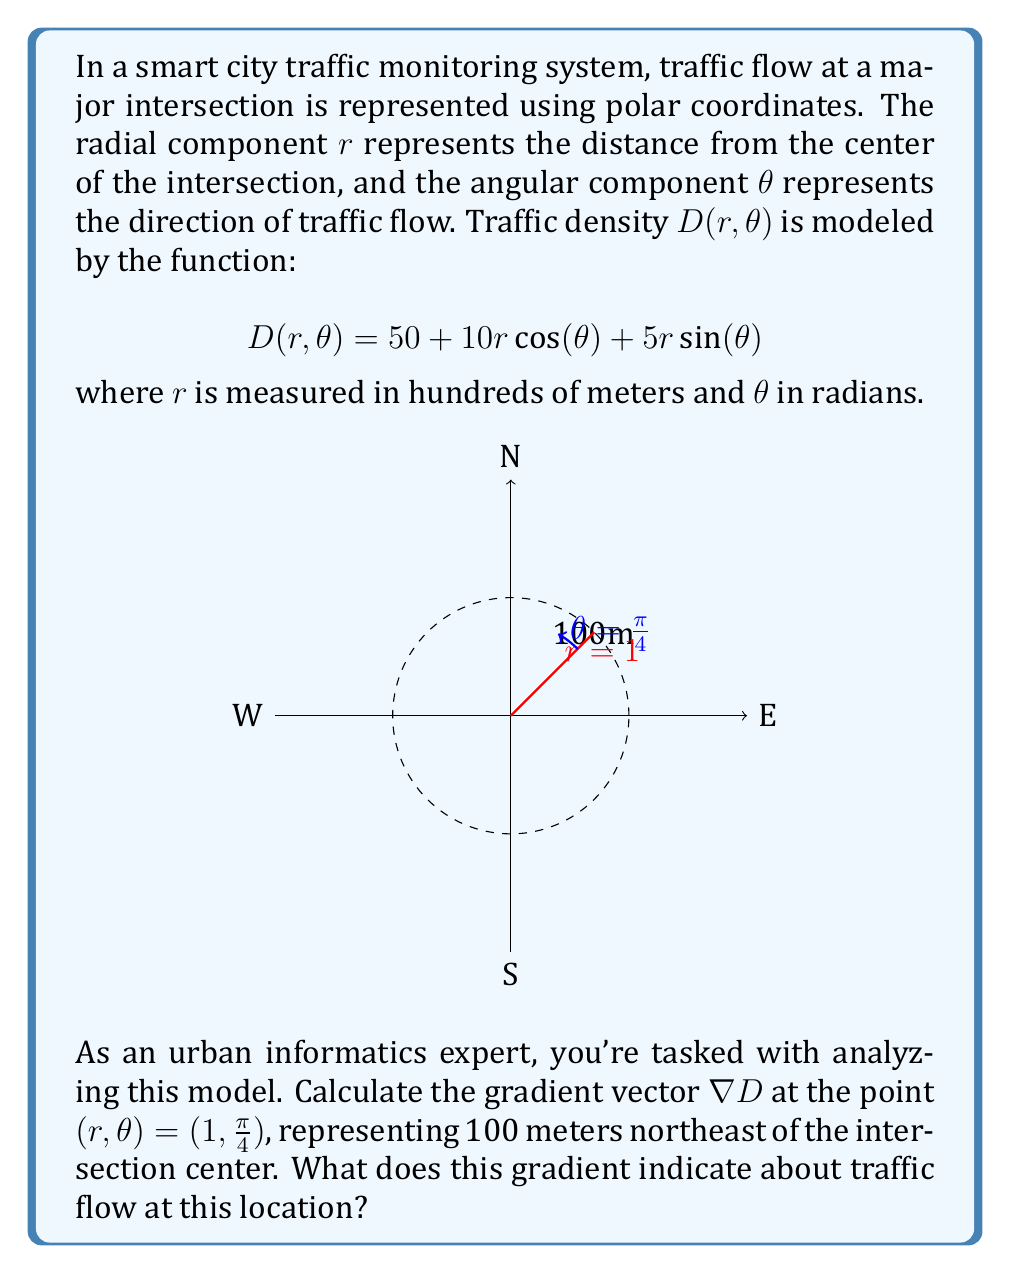Solve this math problem. To solve this problem, we need to follow these steps:

1) First, we need to calculate the partial derivatives of $D$ with respect to $r$ and $\theta$:

   $$\frac{\partial D}{\partial r} = 10\cos(\theta) + 5\sin(\theta)$$
   $$\frac{\partial D}{\partial \theta} = -10r\sin(\theta) + 5r\cos(\theta)$$

2) The gradient in polar coordinates is given by:

   $$\nabla D = \frac{\partial D}{\partial r}\hat{r} + \frac{1}{r}\frac{\partial D}{\partial \theta}\hat{\theta}$$

3) Now, we evaluate these at the point $(r,\theta) = (1, \frac{\pi}{4})$:

   $$\frac{\partial D}{\partial r}\bigg|_{(1,\frac{\pi}{4})} = 10\cos(\frac{\pi}{4}) + 5\sin(\frac{\pi}{4}) = 10\cdot\frac{\sqrt{2}}{2} + 5\cdot\frac{\sqrt{2}}{2} = \frac{15\sqrt{2}}{2}$$

   $$\frac{\partial D}{\partial \theta}\bigg|_{(1,\frac{\pi}{4})} = -10\sin(\frac{\pi}{4}) + 5\cos(\frac{\pi}{4}) = -10\cdot\frac{\sqrt{2}}{2} + 5\cdot\frac{\sqrt{2}}{2} = -\frac{5\sqrt{2}}{2}$$

4) Substituting these values into the gradient formula:

   $$\nabla D = \frac{15\sqrt{2}}{2}\hat{r} + \frac{1}{1}\cdot(-\frac{5\sqrt{2}}{2})\hat{\theta} = \frac{15\sqrt{2}}{2}\hat{r} - \frac{5\sqrt{2}}{2}\hat{\theta}$$

5) Interpretation: The gradient vector points in the direction of steepest increase of the traffic density. The positive radial component ($$\frac{15\sqrt{2}}{2}\hat{r}$$) indicates that traffic density is increasing as we move away from the center of the intersection. The negative angular component ($$-\frac{5\sqrt{2}}{2}\hat{\theta}$$) suggests that traffic density is decreasing as we move counterclockwise from this point.
Answer: $\nabla D = \frac{15\sqrt{2}}{2}\hat{r} - \frac{5\sqrt{2}}{2}\hat{\theta}$; Traffic density increases radially and decreases counterclockwise. 